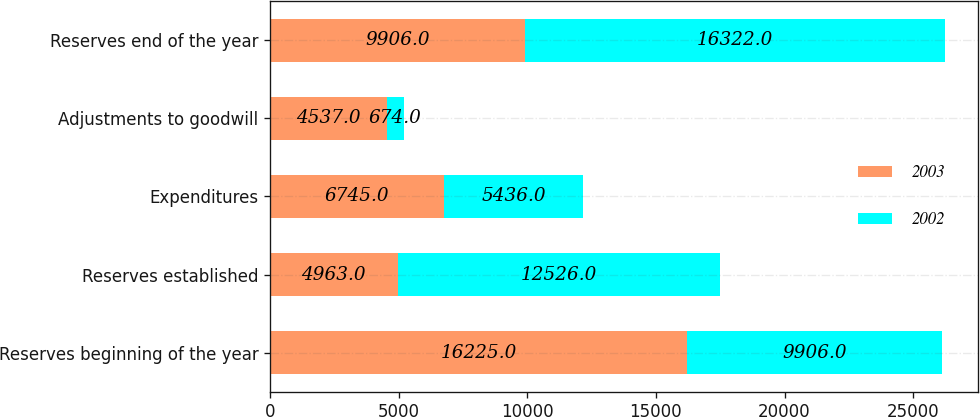Convert chart to OTSL. <chart><loc_0><loc_0><loc_500><loc_500><stacked_bar_chart><ecel><fcel>Reserves beginning of the year<fcel>Reserves established<fcel>Expenditures<fcel>Adjustments to goodwill<fcel>Reserves end of the year<nl><fcel>2003<fcel>16225<fcel>4963<fcel>6745<fcel>4537<fcel>9906<nl><fcel>2002<fcel>9906<fcel>12526<fcel>5436<fcel>674<fcel>16322<nl></chart> 